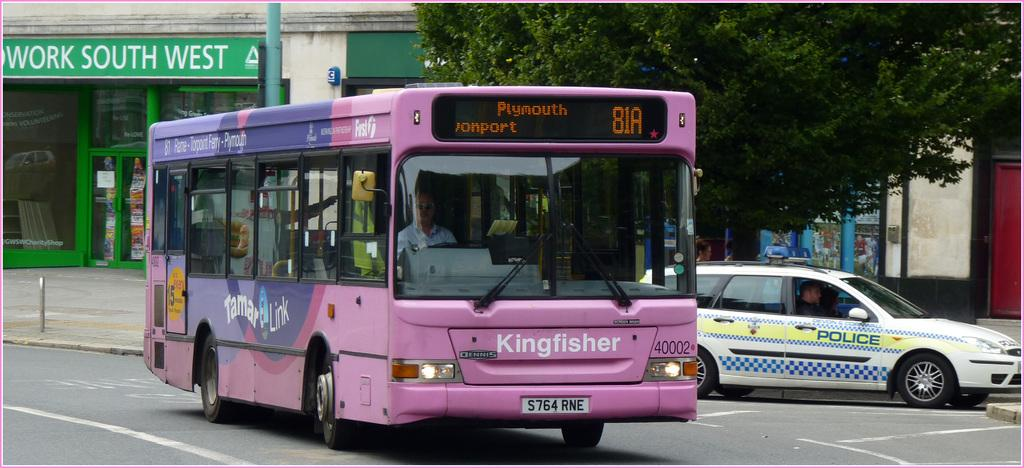<image>
Provide a brief description of the given image. A pink bus is the 81A, and it's registered S764 RNE. 